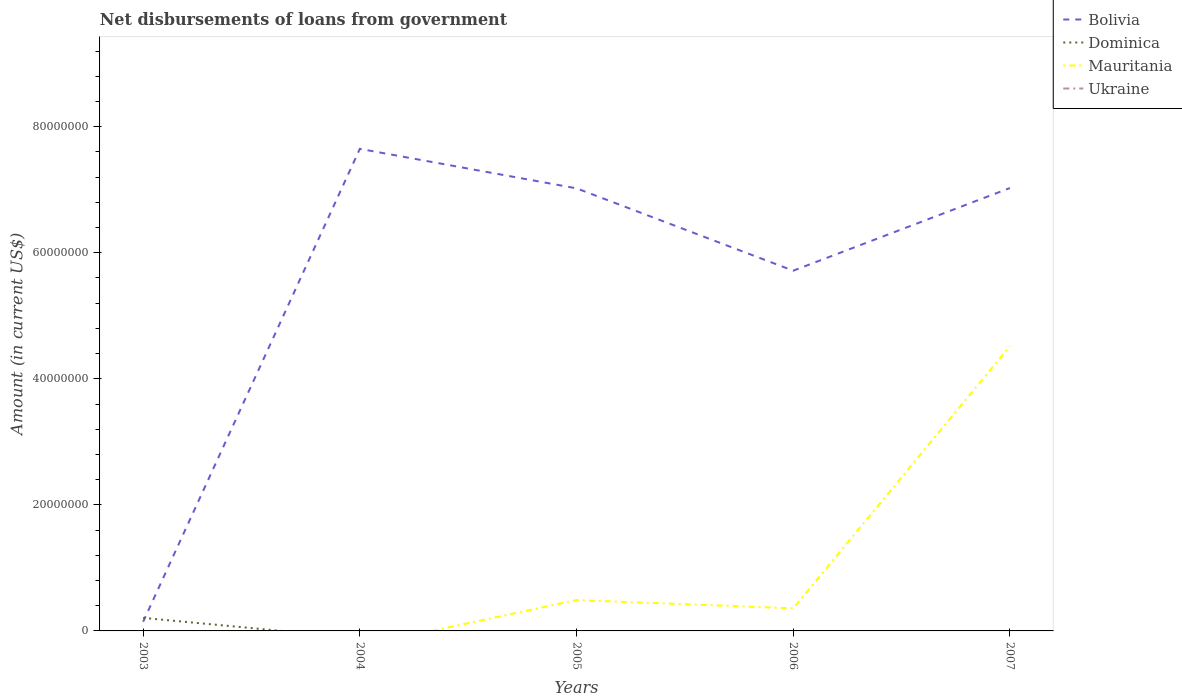How many different coloured lines are there?
Your answer should be very brief. 3. Is the number of lines equal to the number of legend labels?
Your answer should be compact. No. What is the total amount of loan disbursed from government in Bolivia in the graph?
Your answer should be very brief. 1.93e+07. What is the difference between the highest and the second highest amount of loan disbursed from government in Dominica?
Offer a very short reply. 2.07e+06. How many years are there in the graph?
Ensure brevity in your answer.  5. What is the difference between two consecutive major ticks on the Y-axis?
Your answer should be very brief. 2.00e+07. Does the graph contain any zero values?
Give a very brief answer. Yes. Does the graph contain grids?
Offer a very short reply. No. How many legend labels are there?
Make the answer very short. 4. What is the title of the graph?
Your answer should be compact. Net disbursements of loans from government. Does "Norway" appear as one of the legend labels in the graph?
Make the answer very short. No. What is the label or title of the X-axis?
Give a very brief answer. Years. What is the label or title of the Y-axis?
Provide a short and direct response. Amount (in current US$). What is the Amount (in current US$) of Bolivia in 2003?
Give a very brief answer. 1.46e+06. What is the Amount (in current US$) of Dominica in 2003?
Provide a succinct answer. 2.07e+06. What is the Amount (in current US$) of Bolivia in 2004?
Make the answer very short. 7.65e+07. What is the Amount (in current US$) in Dominica in 2004?
Ensure brevity in your answer.  0. What is the Amount (in current US$) of Ukraine in 2004?
Provide a short and direct response. 0. What is the Amount (in current US$) of Bolivia in 2005?
Make the answer very short. 7.02e+07. What is the Amount (in current US$) of Dominica in 2005?
Your answer should be very brief. 0. What is the Amount (in current US$) of Mauritania in 2005?
Offer a very short reply. 4.90e+06. What is the Amount (in current US$) of Ukraine in 2005?
Your response must be concise. 0. What is the Amount (in current US$) in Bolivia in 2006?
Keep it short and to the point. 5.72e+07. What is the Amount (in current US$) in Dominica in 2006?
Your answer should be compact. 0. What is the Amount (in current US$) in Mauritania in 2006?
Your answer should be compact. 3.58e+06. What is the Amount (in current US$) in Ukraine in 2006?
Your answer should be very brief. 0. What is the Amount (in current US$) of Bolivia in 2007?
Make the answer very short. 7.03e+07. What is the Amount (in current US$) in Dominica in 2007?
Provide a short and direct response. 0. What is the Amount (in current US$) of Mauritania in 2007?
Offer a very short reply. 4.52e+07. What is the Amount (in current US$) of Ukraine in 2007?
Provide a short and direct response. 0. Across all years, what is the maximum Amount (in current US$) in Bolivia?
Ensure brevity in your answer.  7.65e+07. Across all years, what is the maximum Amount (in current US$) in Dominica?
Make the answer very short. 2.07e+06. Across all years, what is the maximum Amount (in current US$) of Mauritania?
Give a very brief answer. 4.52e+07. Across all years, what is the minimum Amount (in current US$) of Bolivia?
Offer a terse response. 1.46e+06. What is the total Amount (in current US$) of Bolivia in the graph?
Ensure brevity in your answer.  2.76e+08. What is the total Amount (in current US$) of Dominica in the graph?
Your response must be concise. 2.07e+06. What is the total Amount (in current US$) in Mauritania in the graph?
Ensure brevity in your answer.  5.37e+07. What is the difference between the Amount (in current US$) of Bolivia in 2003 and that in 2004?
Give a very brief answer. -7.50e+07. What is the difference between the Amount (in current US$) in Bolivia in 2003 and that in 2005?
Provide a short and direct response. -6.88e+07. What is the difference between the Amount (in current US$) of Bolivia in 2003 and that in 2006?
Your answer should be very brief. -5.57e+07. What is the difference between the Amount (in current US$) in Bolivia in 2003 and that in 2007?
Make the answer very short. -6.88e+07. What is the difference between the Amount (in current US$) in Bolivia in 2004 and that in 2005?
Your answer should be compact. 6.26e+06. What is the difference between the Amount (in current US$) in Bolivia in 2004 and that in 2006?
Keep it short and to the point. 1.93e+07. What is the difference between the Amount (in current US$) in Bolivia in 2004 and that in 2007?
Offer a very short reply. 6.22e+06. What is the difference between the Amount (in current US$) in Bolivia in 2005 and that in 2006?
Keep it short and to the point. 1.31e+07. What is the difference between the Amount (in current US$) in Mauritania in 2005 and that in 2006?
Offer a terse response. 1.32e+06. What is the difference between the Amount (in current US$) of Bolivia in 2005 and that in 2007?
Your response must be concise. -4.80e+04. What is the difference between the Amount (in current US$) in Mauritania in 2005 and that in 2007?
Provide a succinct answer. -4.03e+07. What is the difference between the Amount (in current US$) of Bolivia in 2006 and that in 2007?
Provide a short and direct response. -1.31e+07. What is the difference between the Amount (in current US$) in Mauritania in 2006 and that in 2007?
Your answer should be very brief. -4.16e+07. What is the difference between the Amount (in current US$) in Bolivia in 2003 and the Amount (in current US$) in Mauritania in 2005?
Provide a succinct answer. -3.44e+06. What is the difference between the Amount (in current US$) in Dominica in 2003 and the Amount (in current US$) in Mauritania in 2005?
Provide a short and direct response. -2.83e+06. What is the difference between the Amount (in current US$) in Bolivia in 2003 and the Amount (in current US$) in Mauritania in 2006?
Your answer should be compact. -2.13e+06. What is the difference between the Amount (in current US$) in Dominica in 2003 and the Amount (in current US$) in Mauritania in 2006?
Your answer should be very brief. -1.51e+06. What is the difference between the Amount (in current US$) of Bolivia in 2003 and the Amount (in current US$) of Mauritania in 2007?
Your answer should be compact. -4.37e+07. What is the difference between the Amount (in current US$) of Dominica in 2003 and the Amount (in current US$) of Mauritania in 2007?
Keep it short and to the point. -4.31e+07. What is the difference between the Amount (in current US$) of Bolivia in 2004 and the Amount (in current US$) of Mauritania in 2005?
Your answer should be very brief. 7.16e+07. What is the difference between the Amount (in current US$) in Bolivia in 2004 and the Amount (in current US$) in Mauritania in 2006?
Keep it short and to the point. 7.29e+07. What is the difference between the Amount (in current US$) of Bolivia in 2004 and the Amount (in current US$) of Mauritania in 2007?
Offer a very short reply. 3.13e+07. What is the difference between the Amount (in current US$) of Bolivia in 2005 and the Amount (in current US$) of Mauritania in 2006?
Provide a succinct answer. 6.66e+07. What is the difference between the Amount (in current US$) of Bolivia in 2005 and the Amount (in current US$) of Mauritania in 2007?
Your answer should be very brief. 2.50e+07. What is the difference between the Amount (in current US$) of Bolivia in 2006 and the Amount (in current US$) of Mauritania in 2007?
Offer a terse response. 1.20e+07. What is the average Amount (in current US$) in Bolivia per year?
Keep it short and to the point. 5.51e+07. What is the average Amount (in current US$) of Dominica per year?
Give a very brief answer. 4.14e+05. What is the average Amount (in current US$) of Mauritania per year?
Offer a very short reply. 1.07e+07. In the year 2003, what is the difference between the Amount (in current US$) in Bolivia and Amount (in current US$) in Dominica?
Ensure brevity in your answer.  -6.12e+05. In the year 2005, what is the difference between the Amount (in current US$) in Bolivia and Amount (in current US$) in Mauritania?
Provide a short and direct response. 6.53e+07. In the year 2006, what is the difference between the Amount (in current US$) in Bolivia and Amount (in current US$) in Mauritania?
Give a very brief answer. 5.36e+07. In the year 2007, what is the difference between the Amount (in current US$) of Bolivia and Amount (in current US$) of Mauritania?
Your answer should be very brief. 2.51e+07. What is the ratio of the Amount (in current US$) in Bolivia in 2003 to that in 2004?
Offer a very short reply. 0.02. What is the ratio of the Amount (in current US$) in Bolivia in 2003 to that in 2005?
Provide a succinct answer. 0.02. What is the ratio of the Amount (in current US$) of Bolivia in 2003 to that in 2006?
Your answer should be very brief. 0.03. What is the ratio of the Amount (in current US$) in Bolivia in 2003 to that in 2007?
Your answer should be compact. 0.02. What is the ratio of the Amount (in current US$) in Bolivia in 2004 to that in 2005?
Give a very brief answer. 1.09. What is the ratio of the Amount (in current US$) in Bolivia in 2004 to that in 2006?
Make the answer very short. 1.34. What is the ratio of the Amount (in current US$) in Bolivia in 2004 to that in 2007?
Your answer should be very brief. 1.09. What is the ratio of the Amount (in current US$) in Bolivia in 2005 to that in 2006?
Give a very brief answer. 1.23. What is the ratio of the Amount (in current US$) in Mauritania in 2005 to that in 2006?
Your answer should be very brief. 1.37. What is the ratio of the Amount (in current US$) of Bolivia in 2005 to that in 2007?
Your answer should be compact. 1. What is the ratio of the Amount (in current US$) of Mauritania in 2005 to that in 2007?
Ensure brevity in your answer.  0.11. What is the ratio of the Amount (in current US$) of Bolivia in 2006 to that in 2007?
Keep it short and to the point. 0.81. What is the ratio of the Amount (in current US$) in Mauritania in 2006 to that in 2007?
Offer a very short reply. 0.08. What is the difference between the highest and the second highest Amount (in current US$) in Bolivia?
Provide a short and direct response. 6.22e+06. What is the difference between the highest and the second highest Amount (in current US$) of Mauritania?
Provide a short and direct response. 4.03e+07. What is the difference between the highest and the lowest Amount (in current US$) in Bolivia?
Your response must be concise. 7.50e+07. What is the difference between the highest and the lowest Amount (in current US$) of Dominica?
Keep it short and to the point. 2.07e+06. What is the difference between the highest and the lowest Amount (in current US$) of Mauritania?
Make the answer very short. 4.52e+07. 